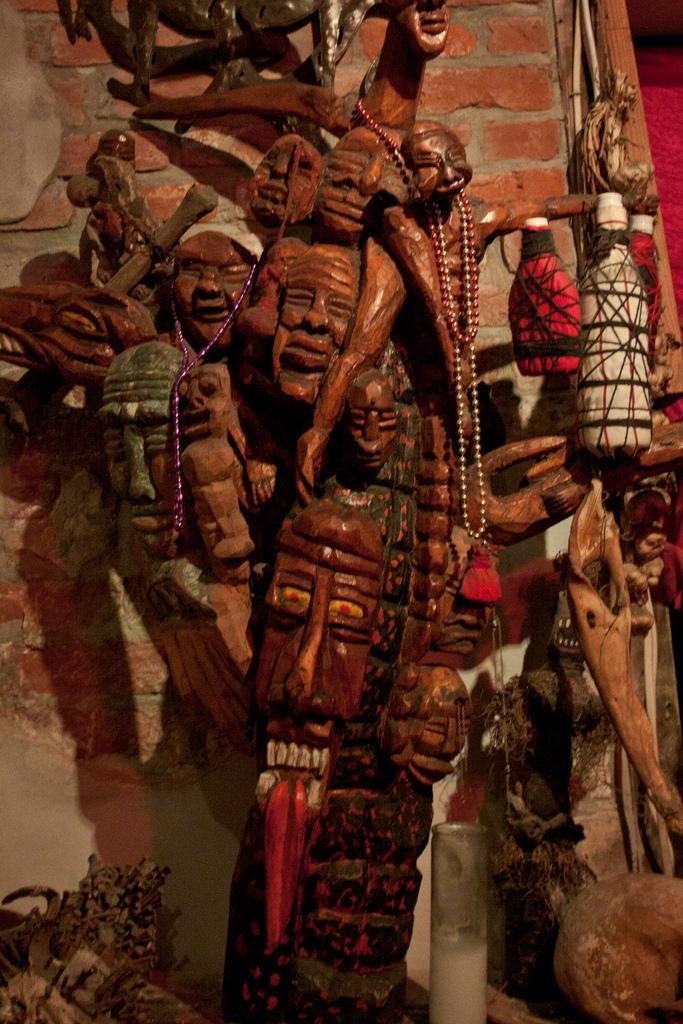Could you give a brief overview of what you see in this image? In this image I can see the architecture. In the background, I can see the wall. 